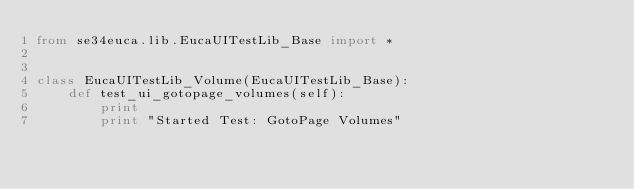Convert code to text. <code><loc_0><loc_0><loc_500><loc_500><_Python_>from se34euca.lib.EucaUITestLib_Base import *


class EucaUITestLib_Volume(EucaUITestLib_Base):
    def test_ui_gotopage_volumes(self):
        print
        print "Started Test: GotoPage Volumes"</code> 